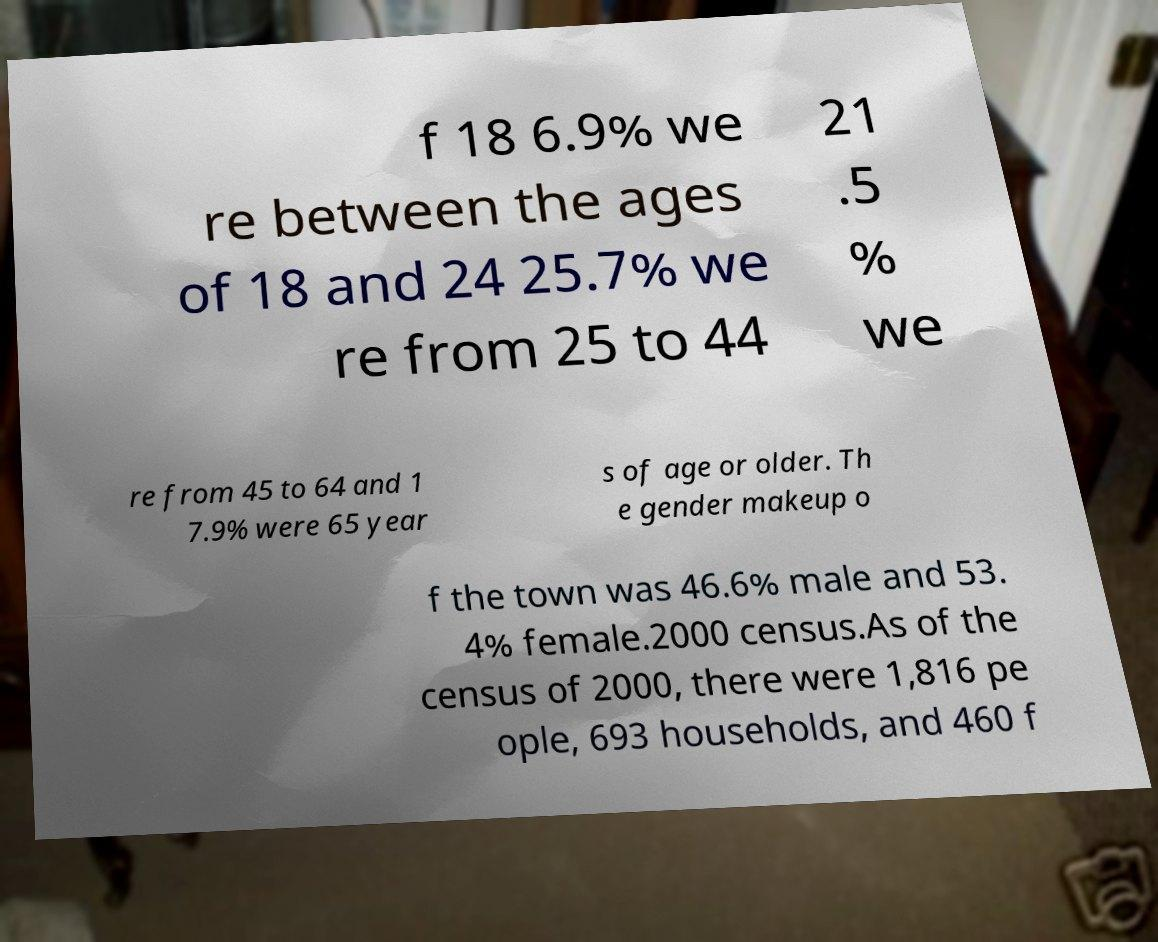Can you read and provide the text displayed in the image?This photo seems to have some interesting text. Can you extract and type it out for me? f 18 6.9% we re between the ages of 18 and 24 25.7% we re from 25 to 44 21 .5 % we re from 45 to 64 and 1 7.9% were 65 year s of age or older. Th e gender makeup o f the town was 46.6% male and 53. 4% female.2000 census.As of the census of 2000, there were 1,816 pe ople, 693 households, and 460 f 